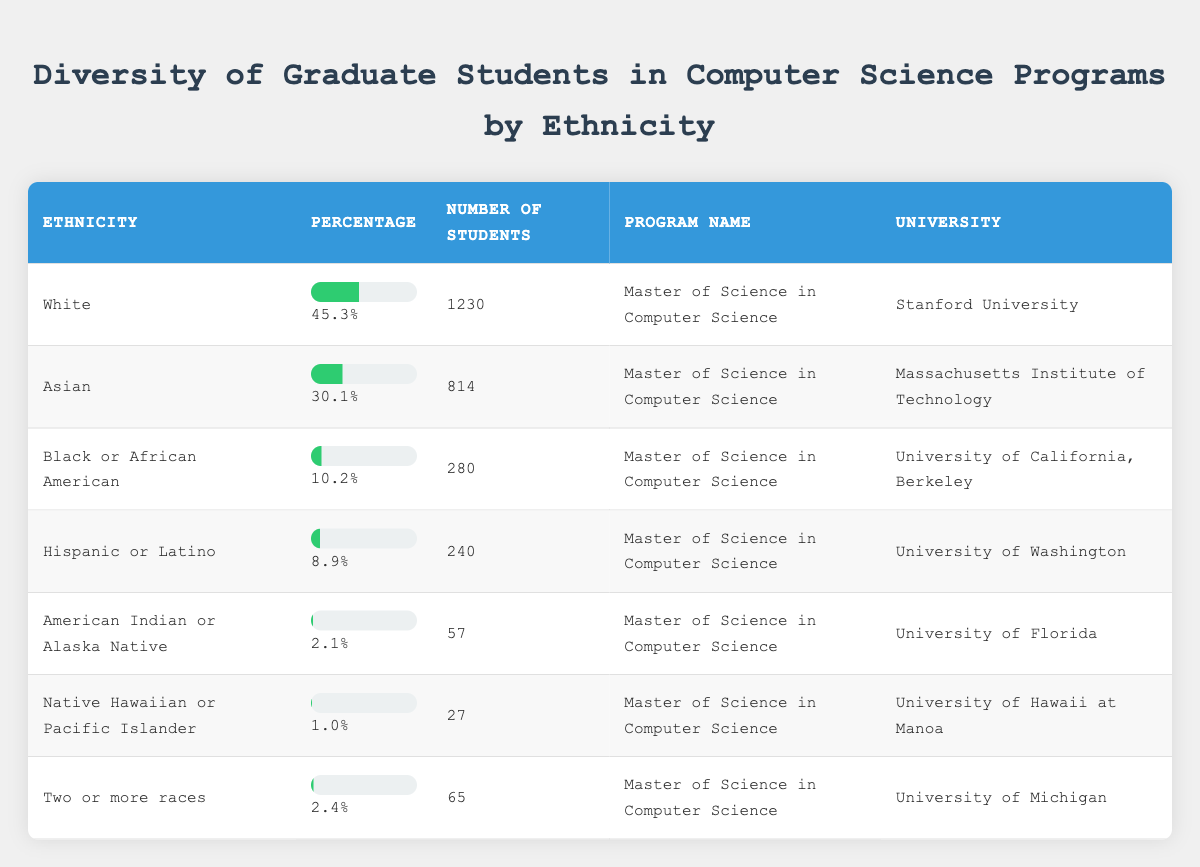What percentage of graduate students in Computer Science are White? From the table, the percentage listed for White students is 45.3%.
Answer: 45.3% Which university has the highest number of Hispanic or Latino graduate students? The table shows that the University of Washington has 240 Hispanic or Latino students, which is the highest among the listed universities.
Answer: University of Washington Are there more Asian students or Black or African American students in the programs listed? The table shows 814 Asian students and 280 Black or African American students. Since 814 is greater than 280, there are more Asian students.
Answer: Yes What is the total number of graduate students from the two smallest ethnic groups combined? The two smallest groups are Native Hawaiian or Pacific Islander with 27 students and American Indian or Alaska Native with 57 students. The total is 27 + 57 = 84.
Answer: 84 Calculate the average percentage of students from all ethnicities listed in the table. The percentages for each group are: 45.3, 30.1, 10.2, 8.9, 2.1, 1.0, 2.4. The total sum of percentages is 45.3 + 30.1 + 10.2 + 8.9 + 2.1 + 1.0 + 2.4 = 100. The average is 100 / 7 ≈ 14.29.
Answer: Approximately 14.29% Is the percentage of students from Two or more races higher than the percentage of American Indian or Alaska Native students? The table shows Two or more races at 2.4% and American Indian or Alaska Native at 2.1%. Since 2.4% is greater than 2.1%, it is higher.
Answer: Yes If we were to rank the ethnicities from highest to lowest percentage, which ethnicity would be in third place? The percentages in order are: White (45.3%), Asian (30.1%), Black or African American (10.2%). Thus, Black or African American is third.
Answer: Black or African American What percentage of the total number of students does the Hispanic or Latino group represent? The total number of students is 1230 (White) + 814 (Asian) + 280 (Black or African American) + 240 (Hispanic or Latino) + 57 (American Indian or Alaska Native) + 27 (Native Hawaiian or Pacific Islander) + 65 (Two or more races) = 2713. Then, for Hispanic or Latino: (240 / 2713) * 100 ≈ 8.84%.
Answer: Approximately 8.84% Which program has the lowest ethnic representation based on percentage? Reviewing the percentages, Native Hawaiian or Pacific Islander shows 1.0%, which is the lowest amongst all groups.
Answer: Native Hawaiian or Pacific Islander What is the difference in the number of students between the White and Asian ethnicities? The number of White students is 1230 and Asian students is 814. The difference is 1230 - 814 = 416.
Answer: 416 